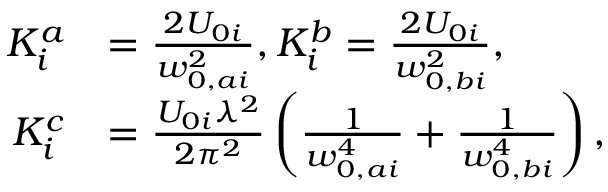<formula> <loc_0><loc_0><loc_500><loc_500>\begin{array} { r l } { K _ { i } ^ { a } } & { = \frac { 2 U _ { 0 i } } { w _ { 0 , a i } ^ { 2 } } , K _ { i } ^ { b } = \frac { 2 U _ { 0 i } } { w _ { 0 , b i } ^ { 2 } } , } \\ { K _ { i } ^ { c } } & { = \frac { U _ { 0 i } \lambda ^ { 2 } } { 2 \pi ^ { 2 } } \left ( \frac { 1 } { w _ { 0 , a i } ^ { 4 } } + \frac { 1 } { w _ { 0 , b i } ^ { 4 } } \right ) , } \end{array}</formula> 